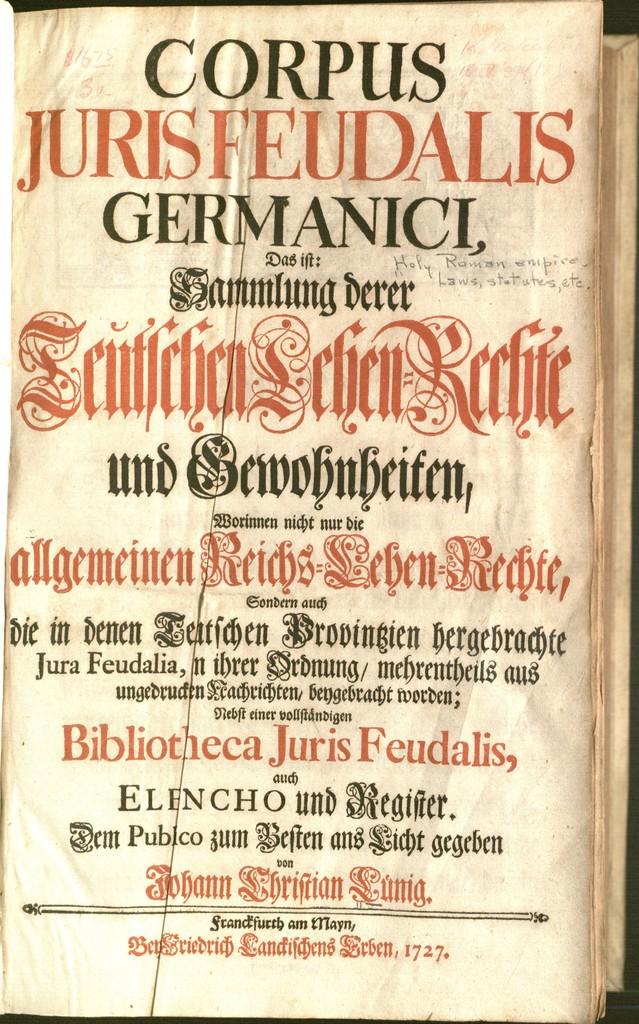What is the title?
Make the answer very short. Corpus jurisfeudalis germanici. 